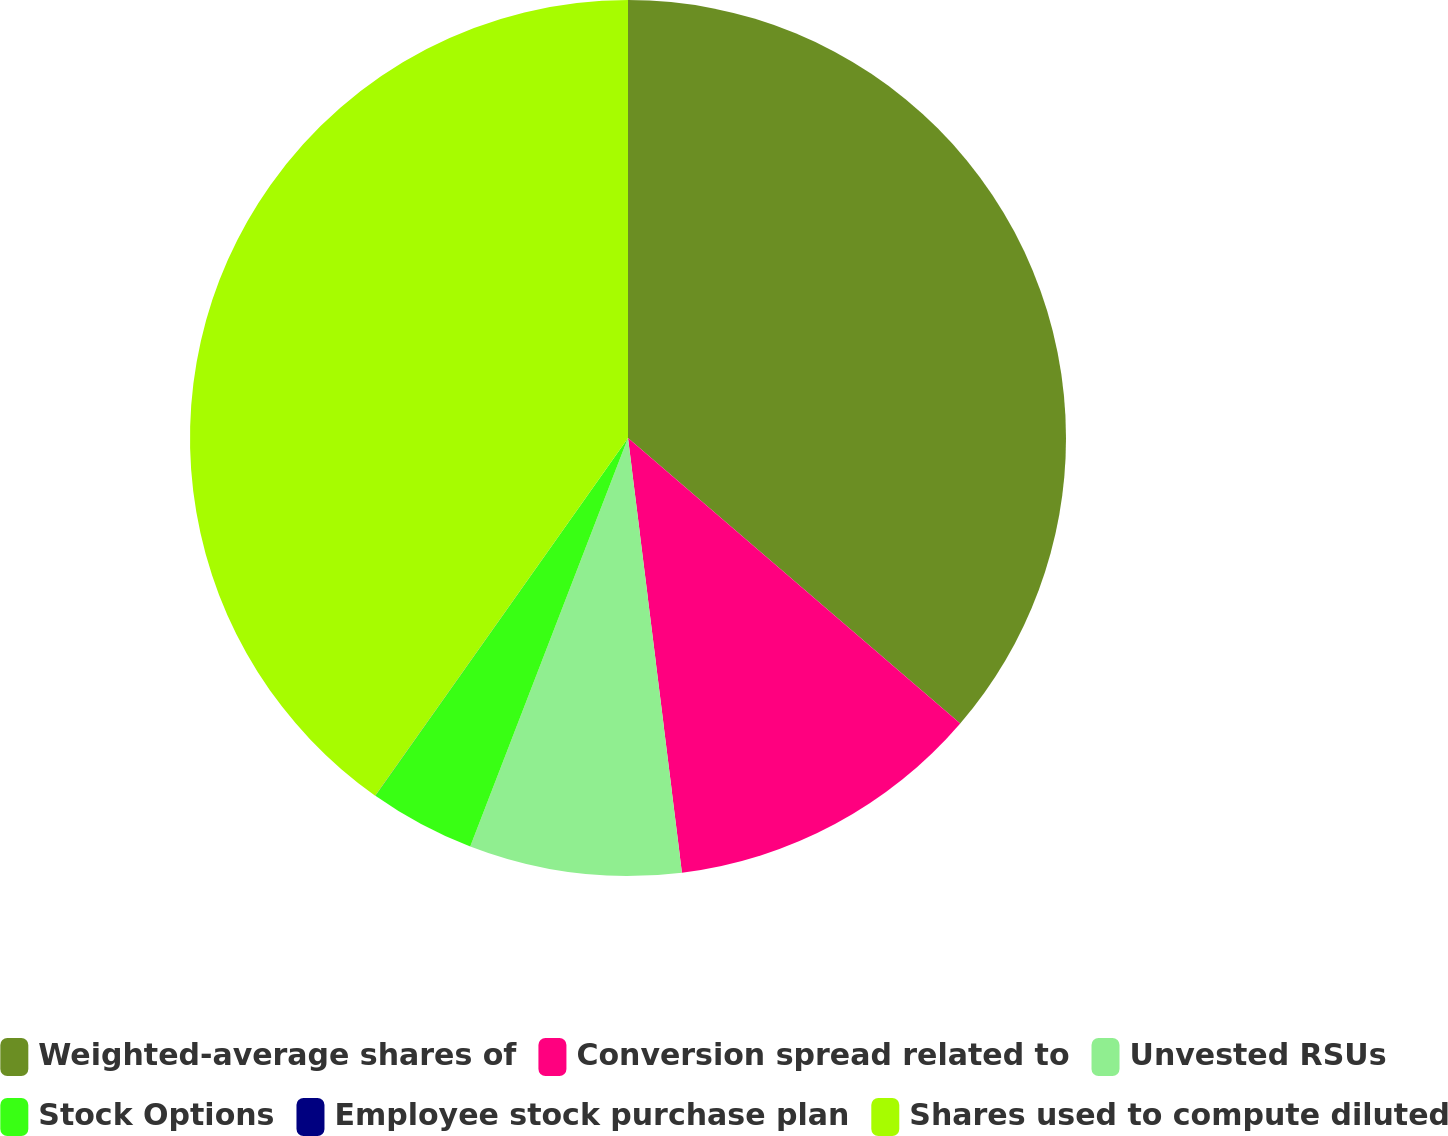Convert chart. <chart><loc_0><loc_0><loc_500><loc_500><pie_chart><fcel>Weighted-average shares of<fcel>Conversion spread related to<fcel>Unvested RSUs<fcel>Stock Options<fcel>Employee stock purchase plan<fcel>Shares used to compute diluted<nl><fcel>36.3%<fcel>11.74%<fcel>7.83%<fcel>3.92%<fcel>0.01%<fcel>40.21%<nl></chart> 